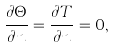Convert formula to latex. <formula><loc_0><loc_0><loc_500><loc_500>\frac { \partial \Theta } { \partial n } = \frac { \partial T } { \partial n } = 0 ,</formula> 